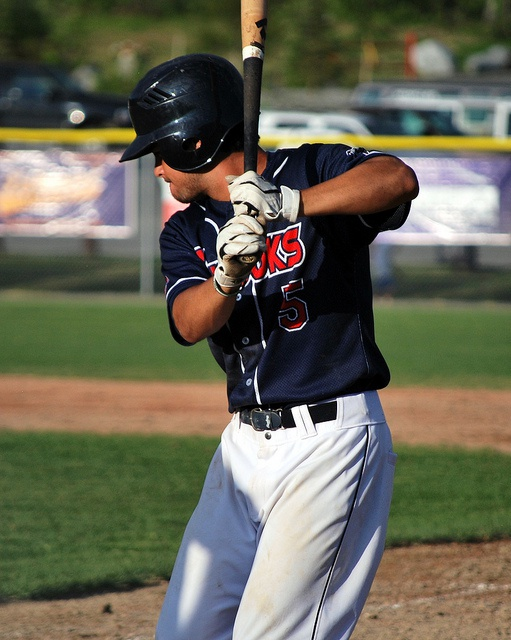Describe the objects in this image and their specific colors. I can see people in darkgreen, black, lightgray, and gray tones, car in darkgreen, black, darkblue, and purple tones, baseball bat in darkgreen, black, and tan tones, and car in darkgreen, darkgray, lightgray, and gray tones in this image. 